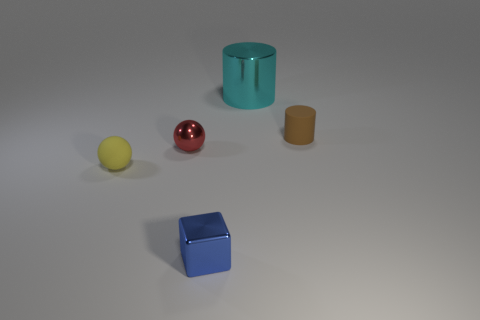Add 2 shiny spheres. How many objects exist? 7 Subtract all cylinders. How many objects are left? 3 Subtract 1 yellow spheres. How many objects are left? 4 Subtract all big red matte objects. Subtract all large metal cylinders. How many objects are left? 4 Add 4 brown matte cylinders. How many brown matte cylinders are left? 5 Add 5 tiny gray blocks. How many tiny gray blocks exist? 5 